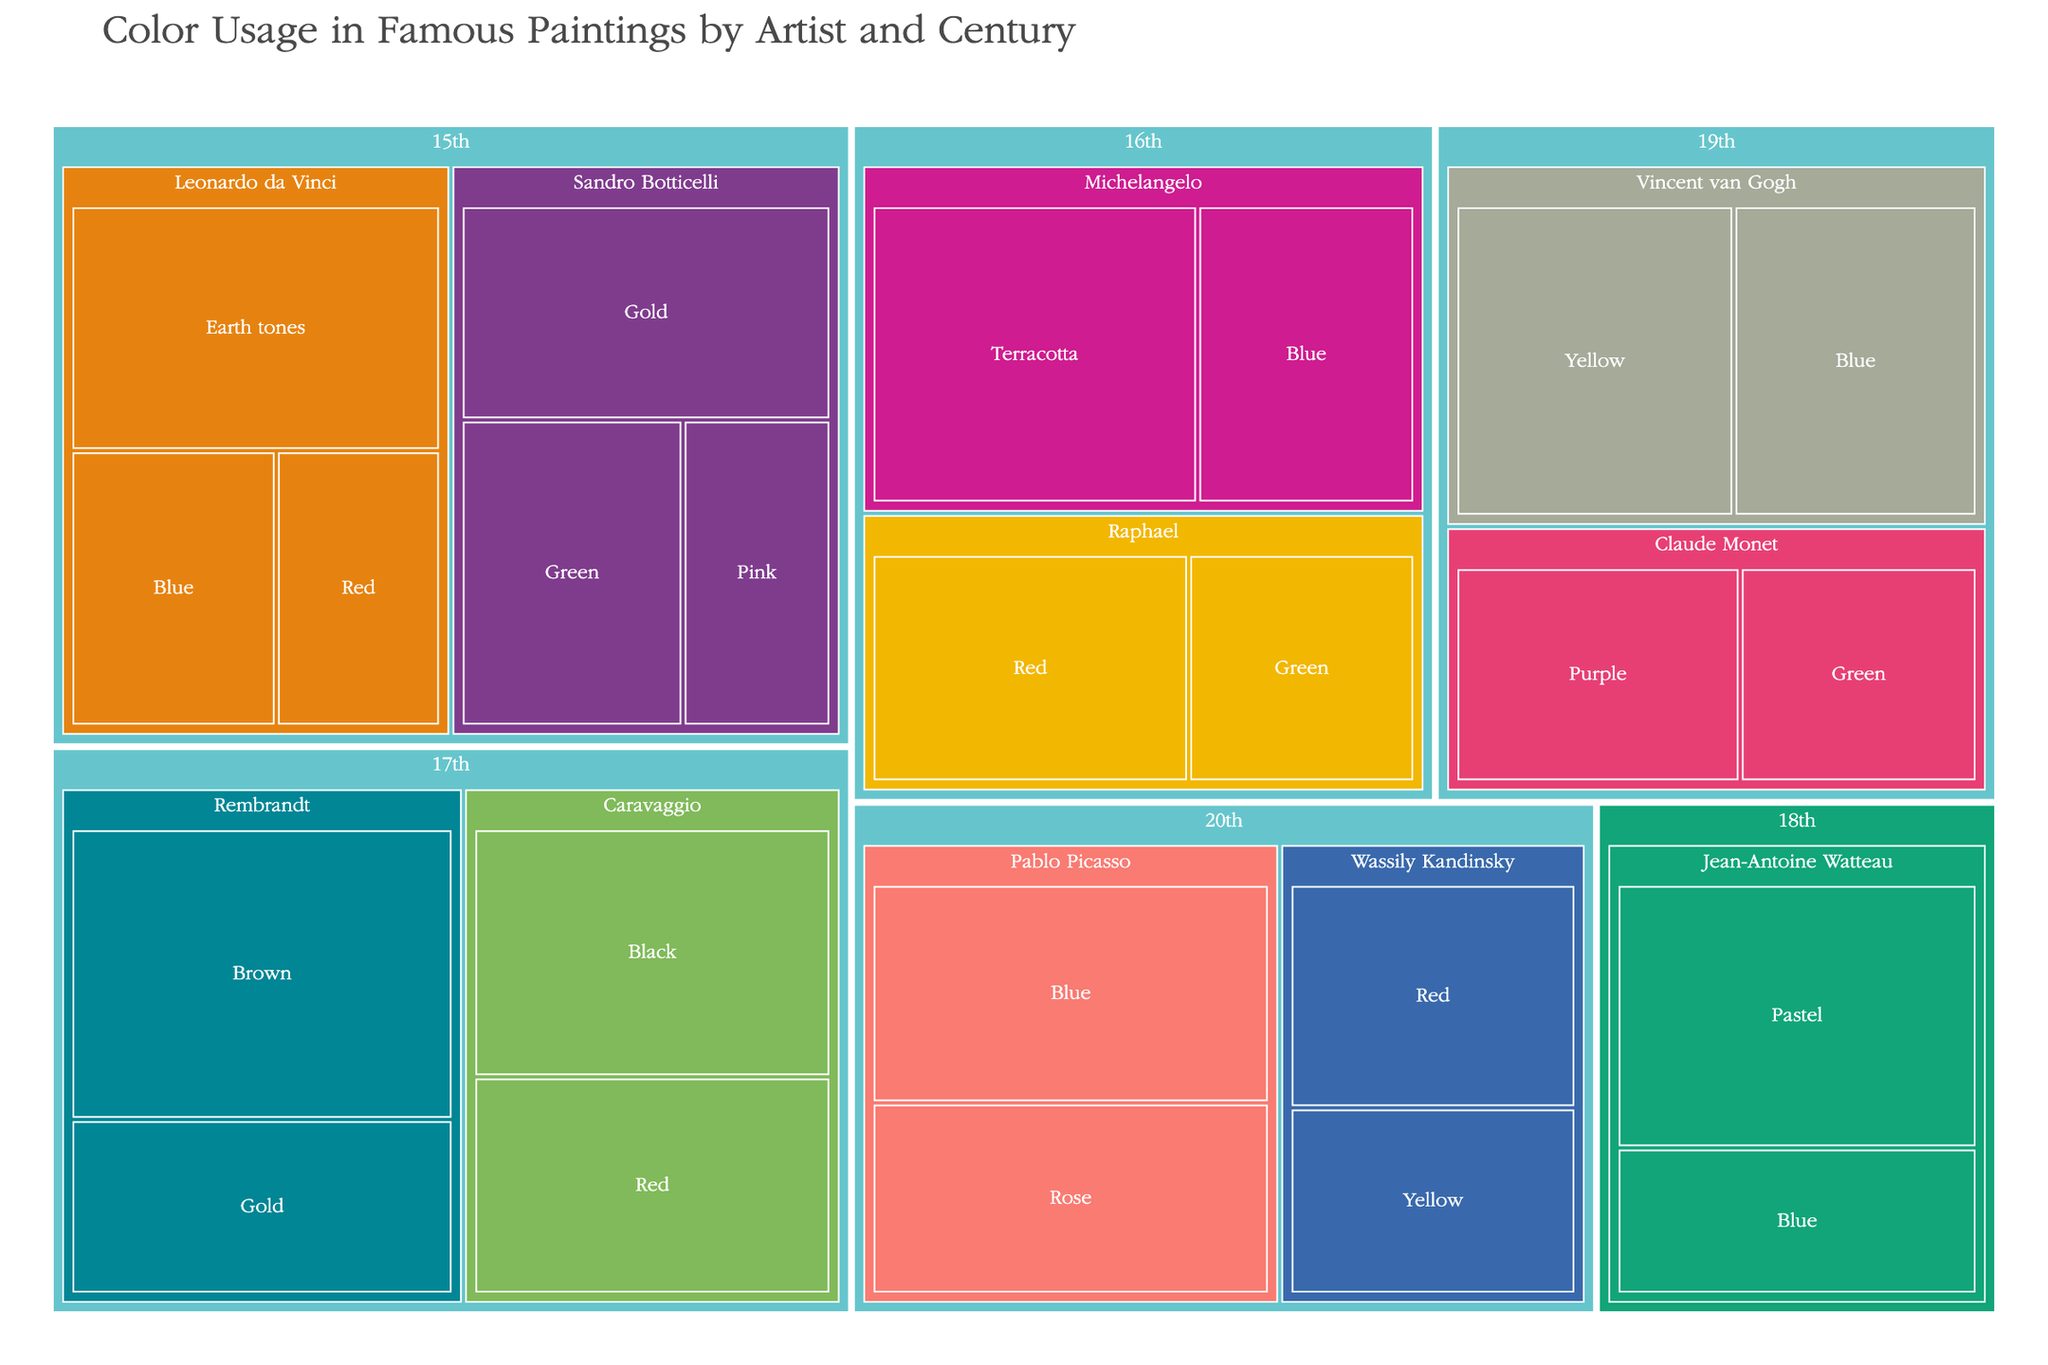What century is focused on the use of the color "Gold" by Sandro Botticelli? Look at the data section for the 15th century, then find Sandro Botticelli and check the listed colors. Gold is used by Sandro Botticelli in the 15th century.
Answer: 15th century Which artist in the 17th century uses the highest percentage of a single color? Examine the treemap section for the 17th century and compare the color percentages for artists within that century. Rembrandt uses Brown at 50%, which is the highest single color usage.
Answer: Rembrandt How many different colors are represented by Vincent van Gogh? Navigate to the 19th century and then to Vincent van Gogh. Count the different colors listed under his name.
Answer: 2 Which artist has the largest percentage usage of the color "Red"? Look across all centuries for artists who have the color "Red" in their data, then compare the percentages. Raphael in the 16th century uses Red at 35%, which is the highest.
Answer: Raphael What's the average percentage of the color Blue used by all artists? Find all the instances of the color Blue, sum their percentages, and divide by the number of instances. Blue is used by Leonardo da Vinci (25%), Michelangelo (30%), Jean-Antoine Watteau (25%), Vincent van Gogh (35%), and Pablo Picasso (40%). The sum is 25+30+25+35+40=155, and there are 5 instances. The average is 155/5.
Answer: 31 In which century did the highest usage of "Earth tones" occur? Look for the color "Earth tones" in the data and examine the corresponding century. Leonardo da Vinci uses 40% of Earth tones in the 15th century.
Answer: 15th century Compare the percentage use of "Blue" by Michelangelo and Vincent van Gogh. Who has a higher percentage? Navigate to the 16th century for Michelangelo (Blue: 30%) and the 19th century for Vincent van Gogh (Blue: 35%). Vincent van Gogh uses Blue at a higher percentage.
Answer: Vincent van Gogh What's the total percentage of "Red" used by all artists combined? Identify all the artists and corresponding centuries who use the color Red, then sum their percentages. Leonardo da Vinci (20%), Raphael (35%), Caravaggio (35%), and Wassily Kandinsky (30%). The total is 20+35+35+30.
Answer: 120 Which two artists have the closest percentage usage of the color "Green"? Look for all instances of the color Green and compare the percentages. Sandro Botticelli uses Green at 30%, Raphael at 25%, and Claude Monet at 25%. Raphael and Claude Monet have the closest percentages.
Answer: Raphael and Claude Monet 